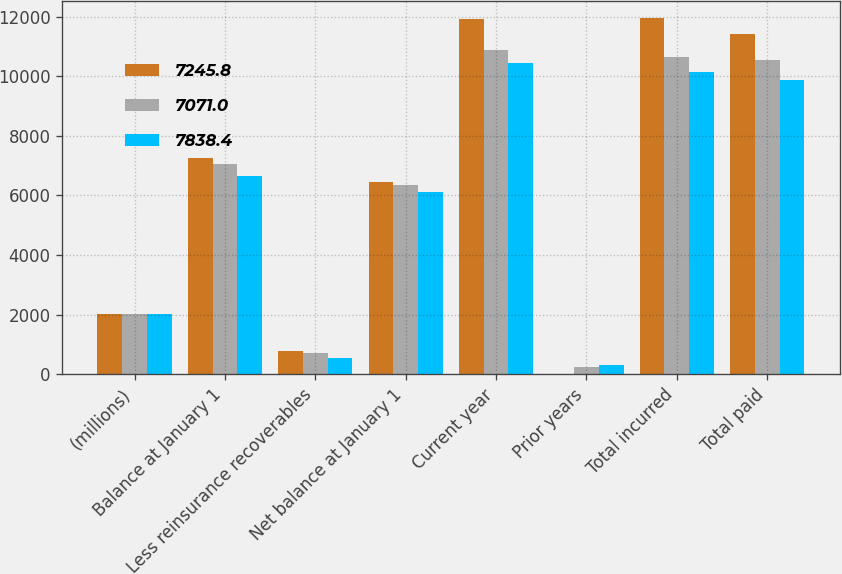Convert chart. <chart><loc_0><loc_0><loc_500><loc_500><stacked_bar_chart><ecel><fcel>(millions)<fcel>Balance at January 1<fcel>Less reinsurance recoverables<fcel>Net balance at January 1<fcel>Current year<fcel>Prior years<fcel>Total incurred<fcel>Total paid<nl><fcel>7245.8<fcel>2012<fcel>7245.8<fcel>785.7<fcel>6460.1<fcel>11926<fcel>22<fcel>11948<fcel>11431.8<nl><fcel>7071<fcel>2011<fcel>7071<fcel>704.1<fcel>6366.9<fcel>10876.8<fcel>242<fcel>10634.8<fcel>10541.6<nl><fcel>7838.4<fcel>2010<fcel>6653<fcel>529.4<fcel>6123.6<fcel>10451.7<fcel>320.4<fcel>10131.3<fcel>9888<nl></chart> 